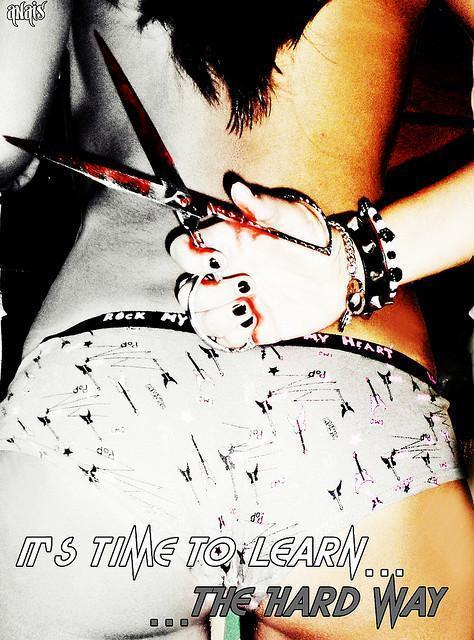How many people are in the picture?
Give a very brief answer. 2. 